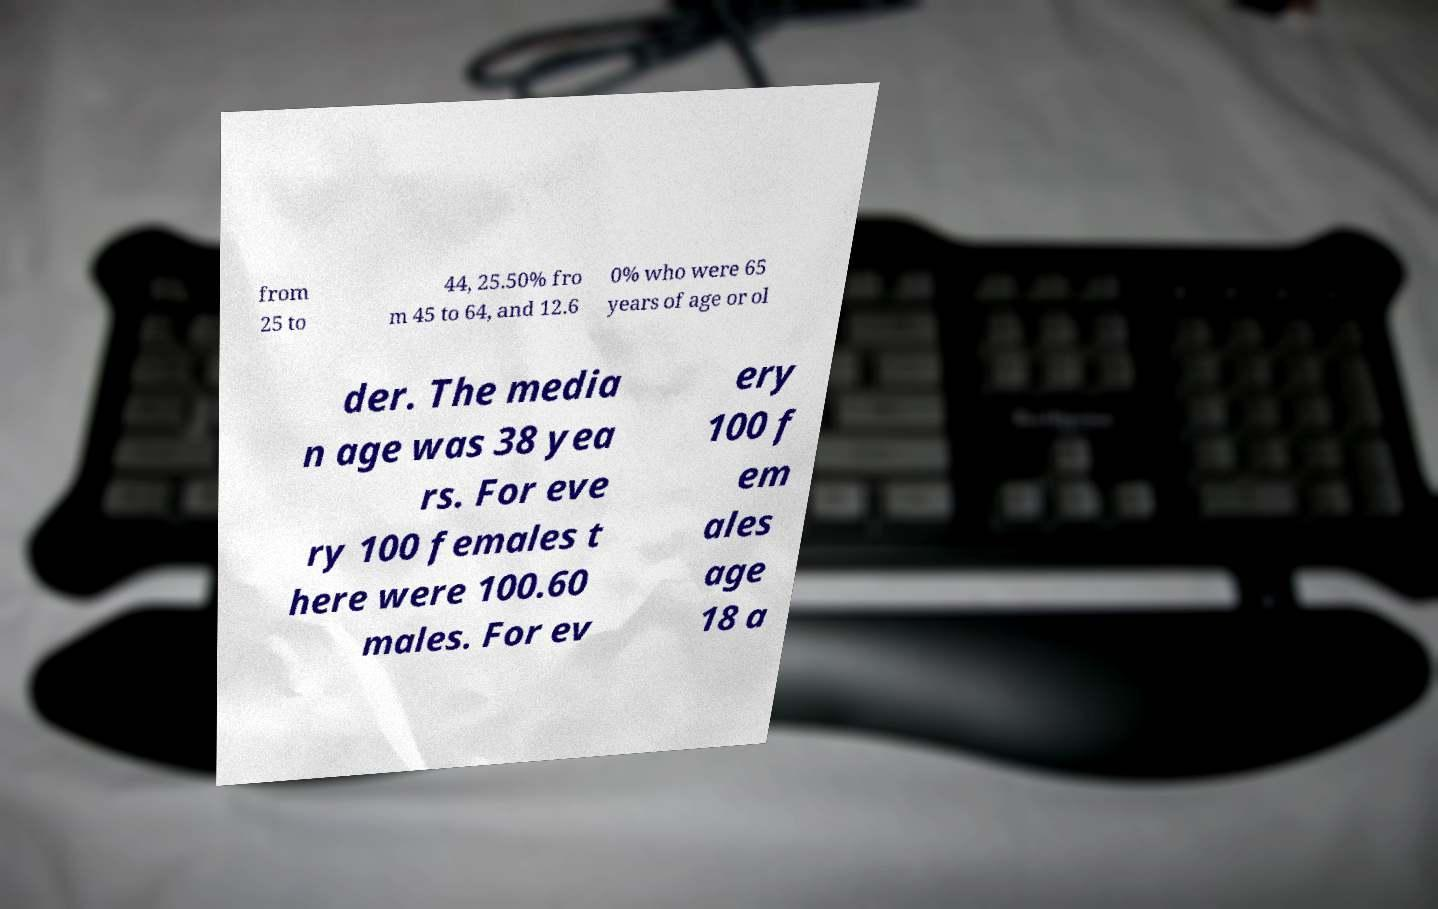Please read and relay the text visible in this image. What does it say? from 25 to 44, 25.50% fro m 45 to 64, and 12.6 0% who were 65 years of age or ol der. The media n age was 38 yea rs. For eve ry 100 females t here were 100.60 males. For ev ery 100 f em ales age 18 a 